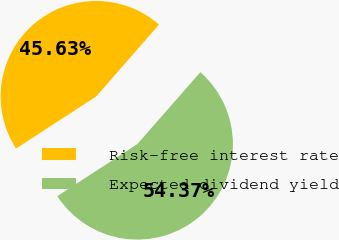Convert chart. <chart><loc_0><loc_0><loc_500><loc_500><pie_chart><fcel>Risk-free interest rate<fcel>Expected dividend yield<nl><fcel>45.63%<fcel>54.37%<nl></chart> 